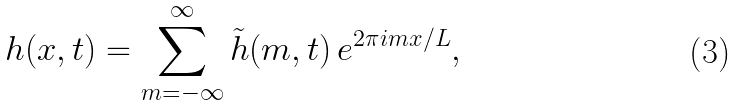Convert formula to latex. <formula><loc_0><loc_0><loc_500><loc_500>h ( x , t ) = \sum _ { m = - \infty } ^ { \infty } { \tilde { h } } ( m , t ) \, e ^ { 2 \pi i m x / L } ,</formula> 